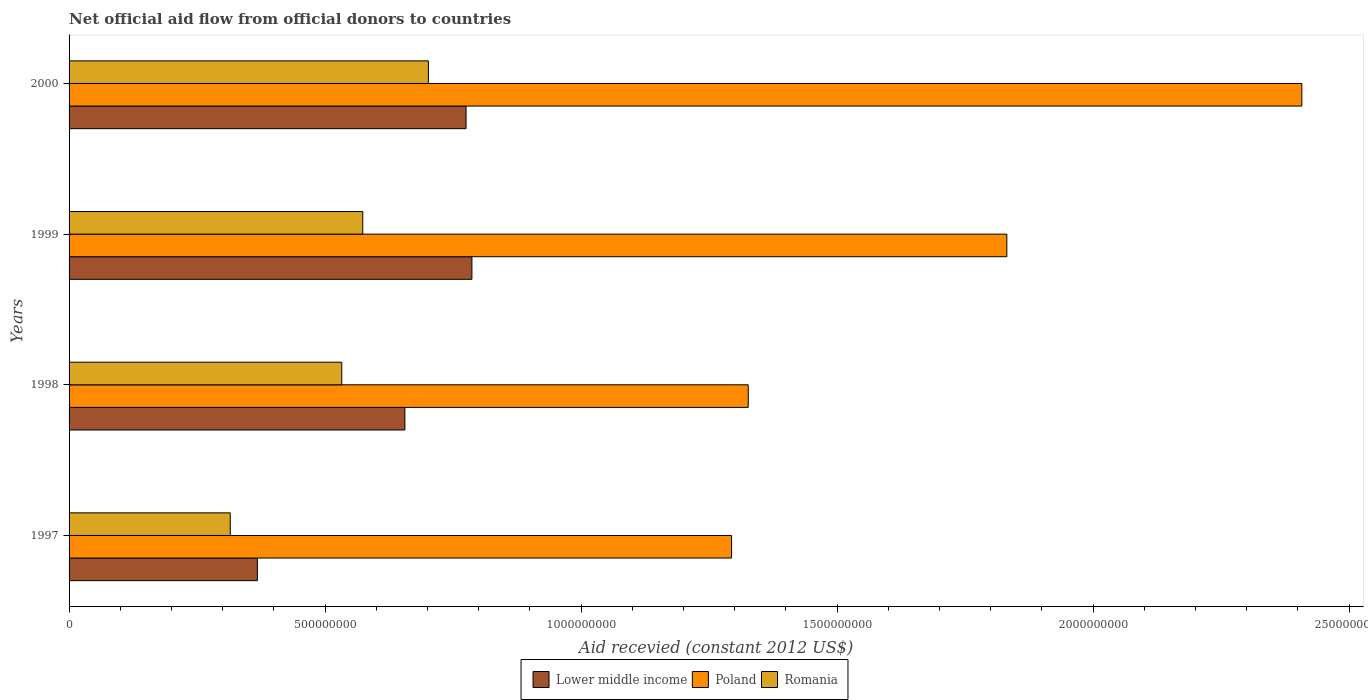How many different coloured bars are there?
Give a very brief answer. 3. How many groups of bars are there?
Offer a very short reply. 4. Are the number of bars per tick equal to the number of legend labels?
Make the answer very short. Yes. Are the number of bars on each tick of the Y-axis equal?
Offer a very short reply. Yes. What is the total aid received in Lower middle income in 2000?
Your response must be concise. 7.75e+08. Across all years, what is the maximum total aid received in Lower middle income?
Your answer should be compact. 7.87e+08. Across all years, what is the minimum total aid received in Poland?
Provide a short and direct response. 1.29e+09. In which year was the total aid received in Lower middle income minimum?
Your answer should be compact. 1997. What is the total total aid received in Romania in the graph?
Make the answer very short. 2.12e+09. What is the difference between the total aid received in Lower middle income in 1998 and that in 2000?
Ensure brevity in your answer.  -1.19e+08. What is the difference between the total aid received in Poland in 2000 and the total aid received in Lower middle income in 1999?
Offer a very short reply. 1.62e+09. What is the average total aid received in Lower middle income per year?
Offer a very short reply. 6.47e+08. In the year 1997, what is the difference between the total aid received in Poland and total aid received in Romania?
Your answer should be very brief. 9.79e+08. In how many years, is the total aid received in Lower middle income greater than 900000000 US$?
Offer a terse response. 0. What is the ratio of the total aid received in Romania in 1998 to that in 1999?
Provide a succinct answer. 0.93. Is the difference between the total aid received in Poland in 1998 and 2000 greater than the difference between the total aid received in Romania in 1998 and 2000?
Provide a succinct answer. No. What is the difference between the highest and the second highest total aid received in Romania?
Your response must be concise. 1.28e+08. What is the difference between the highest and the lowest total aid received in Poland?
Your answer should be compact. 1.11e+09. In how many years, is the total aid received in Romania greater than the average total aid received in Romania taken over all years?
Your answer should be very brief. 3. Is the sum of the total aid received in Romania in 1997 and 1998 greater than the maximum total aid received in Poland across all years?
Make the answer very short. No. What does the 2nd bar from the top in 1997 represents?
Keep it short and to the point. Poland. What does the 3rd bar from the bottom in 1999 represents?
Offer a terse response. Romania. Is it the case that in every year, the sum of the total aid received in Poland and total aid received in Lower middle income is greater than the total aid received in Romania?
Ensure brevity in your answer.  Yes. How many bars are there?
Provide a succinct answer. 12. What is the difference between two consecutive major ticks on the X-axis?
Your response must be concise. 5.00e+08. What is the title of the graph?
Ensure brevity in your answer.  Net official aid flow from official donors to countries. What is the label or title of the X-axis?
Your response must be concise. Aid recevied (constant 2012 US$). What is the Aid recevied (constant 2012 US$) of Lower middle income in 1997?
Give a very brief answer. 3.68e+08. What is the Aid recevied (constant 2012 US$) of Poland in 1997?
Your response must be concise. 1.29e+09. What is the Aid recevied (constant 2012 US$) of Romania in 1997?
Provide a short and direct response. 3.15e+08. What is the Aid recevied (constant 2012 US$) in Lower middle income in 1998?
Provide a succinct answer. 6.56e+08. What is the Aid recevied (constant 2012 US$) in Poland in 1998?
Ensure brevity in your answer.  1.33e+09. What is the Aid recevied (constant 2012 US$) of Romania in 1998?
Your response must be concise. 5.33e+08. What is the Aid recevied (constant 2012 US$) of Lower middle income in 1999?
Keep it short and to the point. 7.87e+08. What is the Aid recevied (constant 2012 US$) in Poland in 1999?
Ensure brevity in your answer.  1.83e+09. What is the Aid recevied (constant 2012 US$) of Romania in 1999?
Make the answer very short. 5.74e+08. What is the Aid recevied (constant 2012 US$) in Lower middle income in 2000?
Keep it short and to the point. 7.75e+08. What is the Aid recevied (constant 2012 US$) in Poland in 2000?
Your answer should be very brief. 2.41e+09. What is the Aid recevied (constant 2012 US$) of Romania in 2000?
Provide a short and direct response. 7.02e+08. Across all years, what is the maximum Aid recevied (constant 2012 US$) of Lower middle income?
Keep it short and to the point. 7.87e+08. Across all years, what is the maximum Aid recevied (constant 2012 US$) of Poland?
Make the answer very short. 2.41e+09. Across all years, what is the maximum Aid recevied (constant 2012 US$) of Romania?
Offer a terse response. 7.02e+08. Across all years, what is the minimum Aid recevied (constant 2012 US$) in Lower middle income?
Ensure brevity in your answer.  3.68e+08. Across all years, what is the minimum Aid recevied (constant 2012 US$) of Poland?
Provide a succinct answer. 1.29e+09. Across all years, what is the minimum Aid recevied (constant 2012 US$) of Romania?
Offer a very short reply. 3.15e+08. What is the total Aid recevied (constant 2012 US$) of Lower middle income in the graph?
Your response must be concise. 2.59e+09. What is the total Aid recevied (constant 2012 US$) of Poland in the graph?
Provide a succinct answer. 6.86e+09. What is the total Aid recevied (constant 2012 US$) in Romania in the graph?
Your response must be concise. 2.12e+09. What is the difference between the Aid recevied (constant 2012 US$) of Lower middle income in 1997 and that in 1998?
Your answer should be very brief. -2.88e+08. What is the difference between the Aid recevied (constant 2012 US$) of Poland in 1997 and that in 1998?
Ensure brevity in your answer.  -3.26e+07. What is the difference between the Aid recevied (constant 2012 US$) of Romania in 1997 and that in 1998?
Your answer should be very brief. -2.18e+08. What is the difference between the Aid recevied (constant 2012 US$) of Lower middle income in 1997 and that in 1999?
Make the answer very short. -4.19e+08. What is the difference between the Aid recevied (constant 2012 US$) of Poland in 1997 and that in 1999?
Your answer should be very brief. -5.38e+08. What is the difference between the Aid recevied (constant 2012 US$) in Romania in 1997 and that in 1999?
Ensure brevity in your answer.  -2.59e+08. What is the difference between the Aid recevied (constant 2012 US$) in Lower middle income in 1997 and that in 2000?
Ensure brevity in your answer.  -4.08e+08. What is the difference between the Aid recevied (constant 2012 US$) of Poland in 1997 and that in 2000?
Make the answer very short. -1.11e+09. What is the difference between the Aid recevied (constant 2012 US$) of Romania in 1997 and that in 2000?
Ensure brevity in your answer.  -3.87e+08. What is the difference between the Aid recevied (constant 2012 US$) in Lower middle income in 1998 and that in 1999?
Your response must be concise. -1.31e+08. What is the difference between the Aid recevied (constant 2012 US$) of Poland in 1998 and that in 1999?
Keep it short and to the point. -5.05e+08. What is the difference between the Aid recevied (constant 2012 US$) in Romania in 1998 and that in 1999?
Your response must be concise. -4.10e+07. What is the difference between the Aid recevied (constant 2012 US$) of Lower middle income in 1998 and that in 2000?
Offer a terse response. -1.19e+08. What is the difference between the Aid recevied (constant 2012 US$) of Poland in 1998 and that in 2000?
Offer a very short reply. -1.08e+09. What is the difference between the Aid recevied (constant 2012 US$) in Romania in 1998 and that in 2000?
Offer a terse response. -1.69e+08. What is the difference between the Aid recevied (constant 2012 US$) in Lower middle income in 1999 and that in 2000?
Your response must be concise. 1.14e+07. What is the difference between the Aid recevied (constant 2012 US$) in Poland in 1999 and that in 2000?
Offer a terse response. -5.76e+08. What is the difference between the Aid recevied (constant 2012 US$) of Romania in 1999 and that in 2000?
Your answer should be compact. -1.28e+08. What is the difference between the Aid recevied (constant 2012 US$) of Lower middle income in 1997 and the Aid recevied (constant 2012 US$) of Poland in 1998?
Ensure brevity in your answer.  -9.59e+08. What is the difference between the Aid recevied (constant 2012 US$) in Lower middle income in 1997 and the Aid recevied (constant 2012 US$) in Romania in 1998?
Your response must be concise. -1.65e+08. What is the difference between the Aid recevied (constant 2012 US$) of Poland in 1997 and the Aid recevied (constant 2012 US$) of Romania in 1998?
Keep it short and to the point. 7.61e+08. What is the difference between the Aid recevied (constant 2012 US$) of Lower middle income in 1997 and the Aid recevied (constant 2012 US$) of Poland in 1999?
Ensure brevity in your answer.  -1.46e+09. What is the difference between the Aid recevied (constant 2012 US$) in Lower middle income in 1997 and the Aid recevied (constant 2012 US$) in Romania in 1999?
Provide a short and direct response. -2.06e+08. What is the difference between the Aid recevied (constant 2012 US$) in Poland in 1997 and the Aid recevied (constant 2012 US$) in Romania in 1999?
Provide a succinct answer. 7.20e+08. What is the difference between the Aid recevied (constant 2012 US$) in Lower middle income in 1997 and the Aid recevied (constant 2012 US$) in Poland in 2000?
Your answer should be compact. -2.04e+09. What is the difference between the Aid recevied (constant 2012 US$) of Lower middle income in 1997 and the Aid recevied (constant 2012 US$) of Romania in 2000?
Provide a short and direct response. -3.34e+08. What is the difference between the Aid recevied (constant 2012 US$) of Poland in 1997 and the Aid recevied (constant 2012 US$) of Romania in 2000?
Provide a short and direct response. 5.92e+08. What is the difference between the Aid recevied (constant 2012 US$) in Lower middle income in 1998 and the Aid recevied (constant 2012 US$) in Poland in 1999?
Your answer should be compact. -1.18e+09. What is the difference between the Aid recevied (constant 2012 US$) in Lower middle income in 1998 and the Aid recevied (constant 2012 US$) in Romania in 1999?
Make the answer very short. 8.23e+07. What is the difference between the Aid recevied (constant 2012 US$) in Poland in 1998 and the Aid recevied (constant 2012 US$) in Romania in 1999?
Keep it short and to the point. 7.53e+08. What is the difference between the Aid recevied (constant 2012 US$) in Lower middle income in 1998 and the Aid recevied (constant 2012 US$) in Poland in 2000?
Keep it short and to the point. -1.75e+09. What is the difference between the Aid recevied (constant 2012 US$) of Lower middle income in 1998 and the Aid recevied (constant 2012 US$) of Romania in 2000?
Your answer should be compact. -4.59e+07. What is the difference between the Aid recevied (constant 2012 US$) of Poland in 1998 and the Aid recevied (constant 2012 US$) of Romania in 2000?
Your answer should be compact. 6.25e+08. What is the difference between the Aid recevied (constant 2012 US$) in Lower middle income in 1999 and the Aid recevied (constant 2012 US$) in Poland in 2000?
Provide a short and direct response. -1.62e+09. What is the difference between the Aid recevied (constant 2012 US$) in Lower middle income in 1999 and the Aid recevied (constant 2012 US$) in Romania in 2000?
Provide a short and direct response. 8.50e+07. What is the difference between the Aid recevied (constant 2012 US$) of Poland in 1999 and the Aid recevied (constant 2012 US$) of Romania in 2000?
Give a very brief answer. 1.13e+09. What is the average Aid recevied (constant 2012 US$) in Lower middle income per year?
Provide a short and direct response. 6.47e+08. What is the average Aid recevied (constant 2012 US$) of Poland per year?
Provide a succinct answer. 1.72e+09. What is the average Aid recevied (constant 2012 US$) of Romania per year?
Offer a very short reply. 5.31e+08. In the year 1997, what is the difference between the Aid recevied (constant 2012 US$) of Lower middle income and Aid recevied (constant 2012 US$) of Poland?
Keep it short and to the point. -9.26e+08. In the year 1997, what is the difference between the Aid recevied (constant 2012 US$) in Lower middle income and Aid recevied (constant 2012 US$) in Romania?
Give a very brief answer. 5.30e+07. In the year 1997, what is the difference between the Aid recevied (constant 2012 US$) in Poland and Aid recevied (constant 2012 US$) in Romania?
Offer a very short reply. 9.79e+08. In the year 1998, what is the difference between the Aid recevied (constant 2012 US$) of Lower middle income and Aid recevied (constant 2012 US$) of Poland?
Provide a succinct answer. -6.71e+08. In the year 1998, what is the difference between the Aid recevied (constant 2012 US$) of Lower middle income and Aid recevied (constant 2012 US$) of Romania?
Give a very brief answer. 1.23e+08. In the year 1998, what is the difference between the Aid recevied (constant 2012 US$) in Poland and Aid recevied (constant 2012 US$) in Romania?
Make the answer very short. 7.94e+08. In the year 1999, what is the difference between the Aid recevied (constant 2012 US$) in Lower middle income and Aid recevied (constant 2012 US$) in Poland?
Offer a terse response. -1.04e+09. In the year 1999, what is the difference between the Aid recevied (constant 2012 US$) of Lower middle income and Aid recevied (constant 2012 US$) of Romania?
Provide a short and direct response. 2.13e+08. In the year 1999, what is the difference between the Aid recevied (constant 2012 US$) of Poland and Aid recevied (constant 2012 US$) of Romania?
Your response must be concise. 1.26e+09. In the year 2000, what is the difference between the Aid recevied (constant 2012 US$) in Lower middle income and Aid recevied (constant 2012 US$) in Poland?
Your answer should be compact. -1.63e+09. In the year 2000, what is the difference between the Aid recevied (constant 2012 US$) in Lower middle income and Aid recevied (constant 2012 US$) in Romania?
Your answer should be compact. 7.36e+07. In the year 2000, what is the difference between the Aid recevied (constant 2012 US$) in Poland and Aid recevied (constant 2012 US$) in Romania?
Ensure brevity in your answer.  1.71e+09. What is the ratio of the Aid recevied (constant 2012 US$) in Lower middle income in 1997 to that in 1998?
Ensure brevity in your answer.  0.56. What is the ratio of the Aid recevied (constant 2012 US$) in Poland in 1997 to that in 1998?
Provide a succinct answer. 0.98. What is the ratio of the Aid recevied (constant 2012 US$) of Romania in 1997 to that in 1998?
Ensure brevity in your answer.  0.59. What is the ratio of the Aid recevied (constant 2012 US$) in Lower middle income in 1997 to that in 1999?
Provide a succinct answer. 0.47. What is the ratio of the Aid recevied (constant 2012 US$) in Poland in 1997 to that in 1999?
Ensure brevity in your answer.  0.71. What is the ratio of the Aid recevied (constant 2012 US$) in Romania in 1997 to that in 1999?
Your answer should be compact. 0.55. What is the ratio of the Aid recevied (constant 2012 US$) in Lower middle income in 1997 to that in 2000?
Keep it short and to the point. 0.47. What is the ratio of the Aid recevied (constant 2012 US$) in Poland in 1997 to that in 2000?
Your response must be concise. 0.54. What is the ratio of the Aid recevied (constant 2012 US$) in Romania in 1997 to that in 2000?
Your answer should be compact. 0.45. What is the ratio of the Aid recevied (constant 2012 US$) in Lower middle income in 1998 to that in 1999?
Provide a succinct answer. 0.83. What is the ratio of the Aid recevied (constant 2012 US$) in Poland in 1998 to that in 1999?
Your answer should be very brief. 0.72. What is the ratio of the Aid recevied (constant 2012 US$) of Romania in 1998 to that in 1999?
Make the answer very short. 0.93. What is the ratio of the Aid recevied (constant 2012 US$) of Lower middle income in 1998 to that in 2000?
Give a very brief answer. 0.85. What is the ratio of the Aid recevied (constant 2012 US$) of Poland in 1998 to that in 2000?
Ensure brevity in your answer.  0.55. What is the ratio of the Aid recevied (constant 2012 US$) in Romania in 1998 to that in 2000?
Your answer should be compact. 0.76. What is the ratio of the Aid recevied (constant 2012 US$) in Lower middle income in 1999 to that in 2000?
Ensure brevity in your answer.  1.01. What is the ratio of the Aid recevied (constant 2012 US$) of Poland in 1999 to that in 2000?
Give a very brief answer. 0.76. What is the ratio of the Aid recevied (constant 2012 US$) of Romania in 1999 to that in 2000?
Offer a terse response. 0.82. What is the difference between the highest and the second highest Aid recevied (constant 2012 US$) of Lower middle income?
Ensure brevity in your answer.  1.14e+07. What is the difference between the highest and the second highest Aid recevied (constant 2012 US$) of Poland?
Your response must be concise. 5.76e+08. What is the difference between the highest and the second highest Aid recevied (constant 2012 US$) of Romania?
Offer a terse response. 1.28e+08. What is the difference between the highest and the lowest Aid recevied (constant 2012 US$) in Lower middle income?
Keep it short and to the point. 4.19e+08. What is the difference between the highest and the lowest Aid recevied (constant 2012 US$) of Poland?
Provide a succinct answer. 1.11e+09. What is the difference between the highest and the lowest Aid recevied (constant 2012 US$) of Romania?
Make the answer very short. 3.87e+08. 